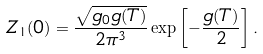<formula> <loc_0><loc_0><loc_500><loc_500>Z _ { 1 } ( 0 ) = \frac { \sqrt { g _ { 0 } g ( T ) } } { 2 \pi ^ { 3 } } \exp \left [ - \frac { g ( T ) } { 2 } \right ] .</formula> 